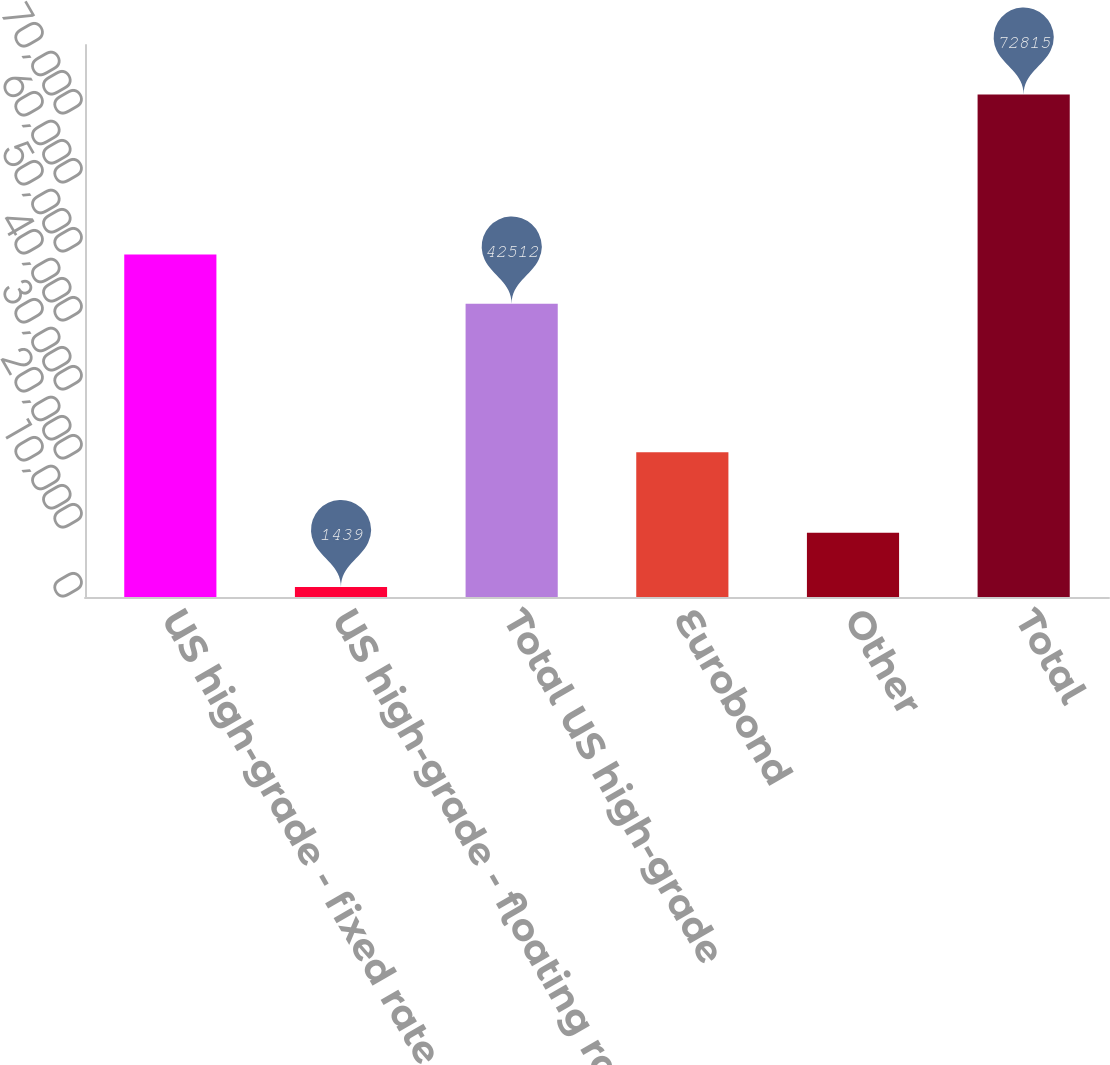<chart> <loc_0><loc_0><loc_500><loc_500><bar_chart><fcel>US high-grade - fixed rate<fcel>US high-grade - floating rate<fcel>Total US high-grade<fcel>Eurobond<fcel>Other<fcel>Total<nl><fcel>49649.6<fcel>1439<fcel>42512<fcel>20990<fcel>9313<fcel>72815<nl></chart> 